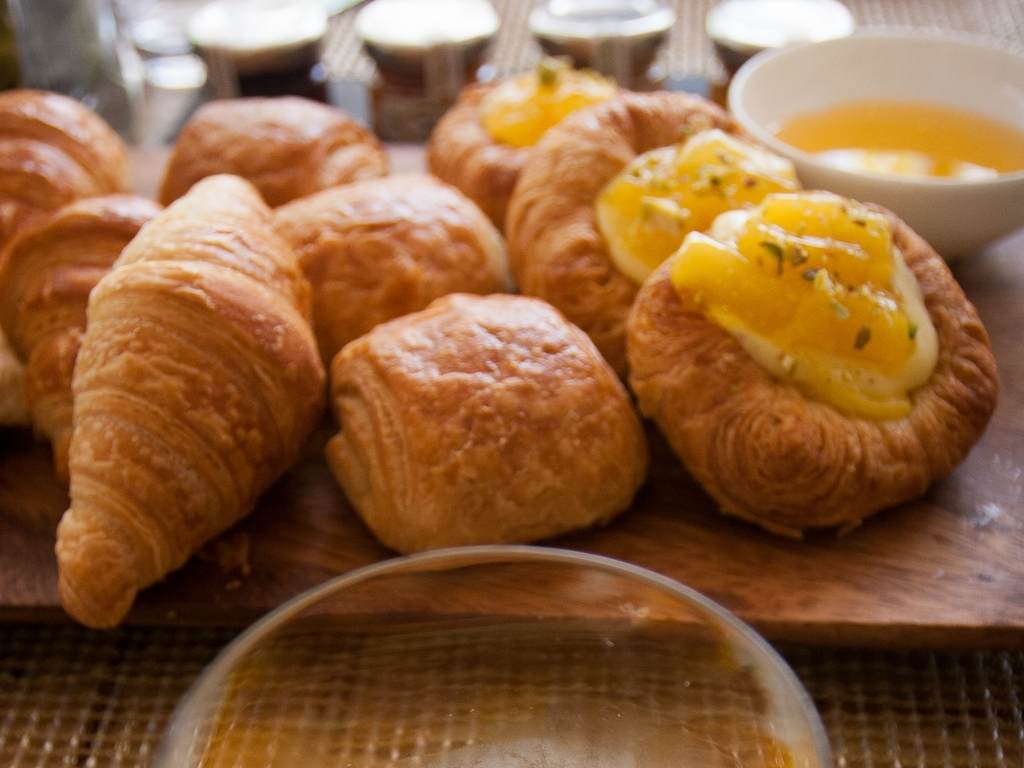What could be improved in this photo? To improve the photo, ensuring the main subjects—croissants and pastries—are in focus would enhance the clarity and make them more visually appealing. Better lighting could be used to reduce the shadows and highlight the textures and colors of the food. A cleaner composition with fewer elements in the background could also help the primary subject stand out more. 